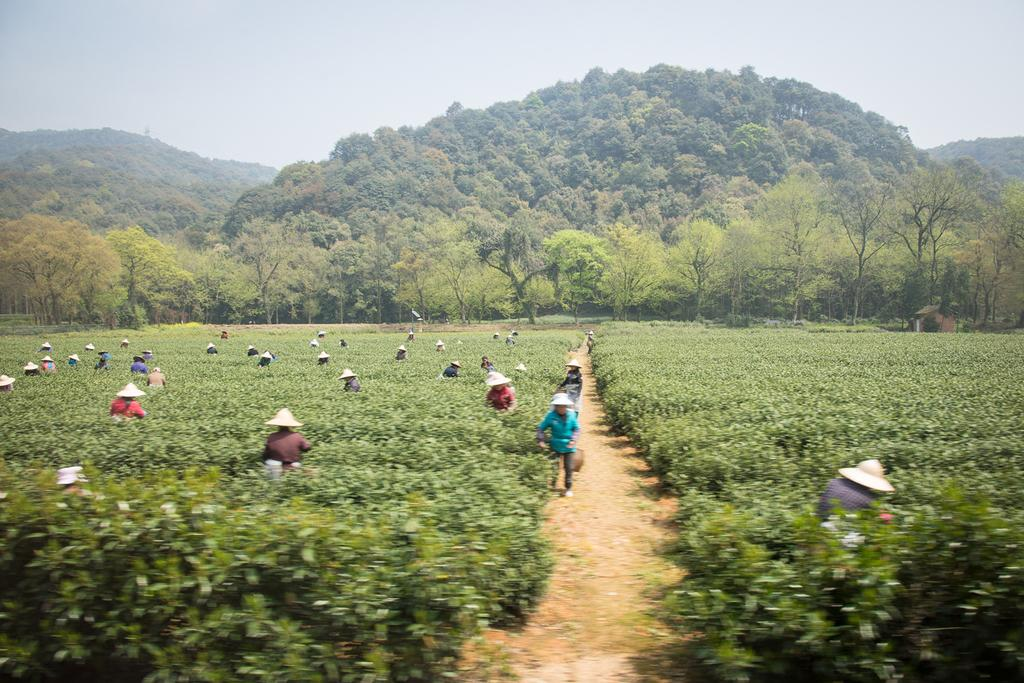What type of natural elements can be seen in the image? There are trees and hills visible in the image. What are the people in the image wearing on their heads? The people are wearing caps on their heads. What type of vegetation is present in the image? There are plants in the image. What is the condition of the sky in the image? The sky is cloudy in the image. What type of development project is being discussed by the people in the image? There is no indication in the image that the people are discussing any development projects. Can you tell me what card game the people are playing in the image? There is no card game or any cards visible in the image. 